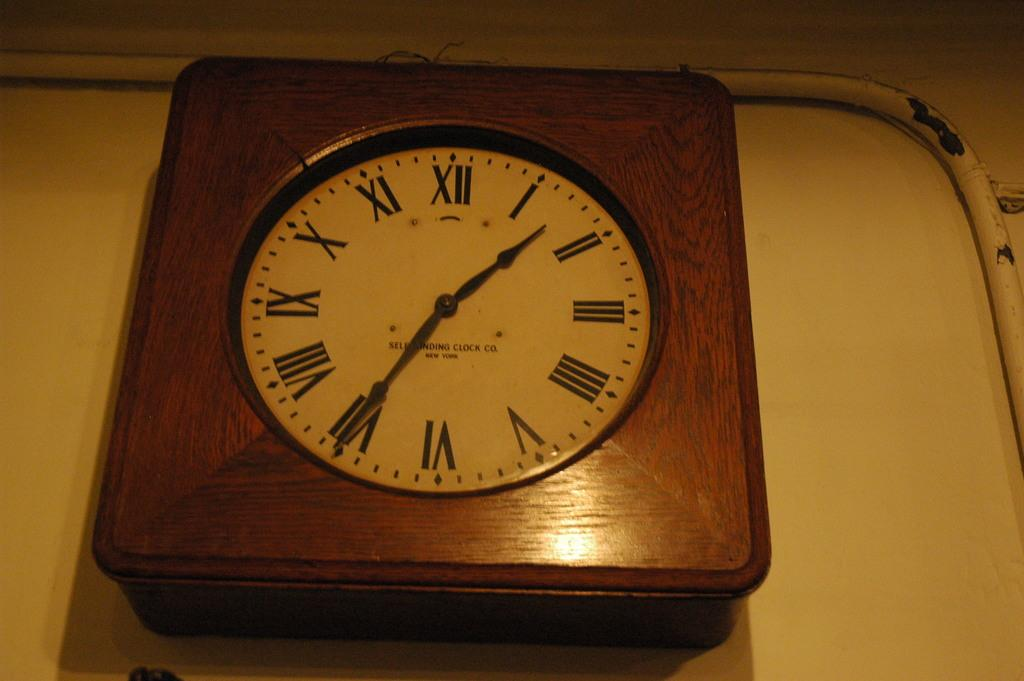<image>
Offer a succinct explanation of the picture presented. a clock that has the roman numeral XII on it 